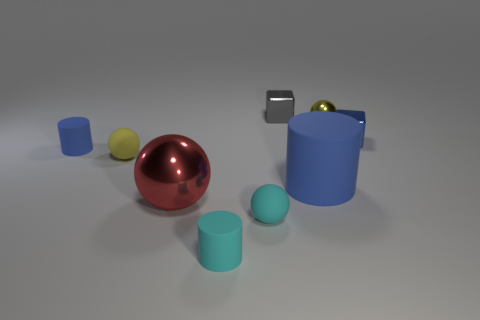Subtract all purple cylinders. How many yellow balls are left? 2 Subtract all cyan rubber cylinders. How many cylinders are left? 2 Subtract all red balls. How many balls are left? 3 Add 1 large shiny objects. How many objects exist? 10 Add 1 small metal things. How many small metal things exist? 4 Subtract 1 red spheres. How many objects are left? 8 Subtract all cubes. How many objects are left? 7 Subtract all gray balls. Subtract all brown cylinders. How many balls are left? 4 Subtract all red spheres. Subtract all yellow metallic balls. How many objects are left? 7 Add 1 rubber things. How many rubber things are left? 6 